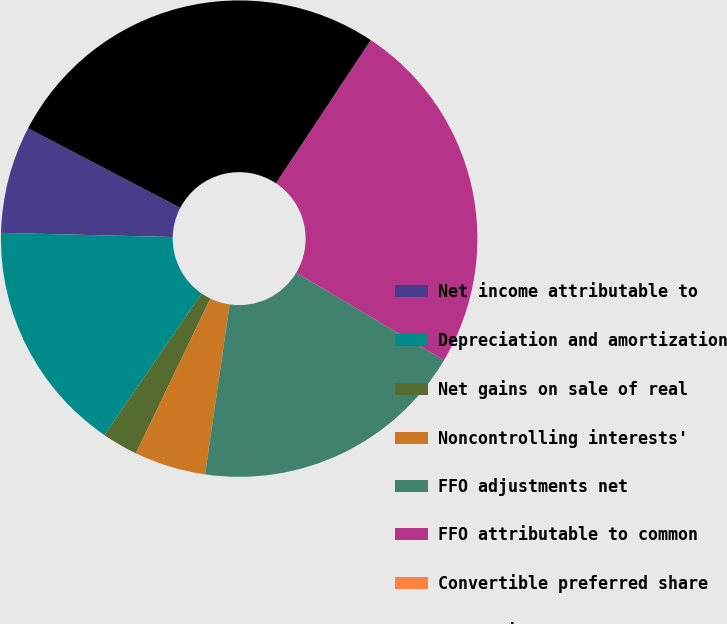<chart> <loc_0><loc_0><loc_500><loc_500><pie_chart><fcel>Net income attributable to<fcel>Depreciation and amortization<fcel>Net gains on sale of real<fcel>Noncontrolling interests'<fcel>FFO adjustments net<fcel>FFO attributable to common<fcel>Convertible preferred share<fcel>conversions<nl><fcel>7.28%<fcel>15.82%<fcel>2.43%<fcel>4.85%<fcel>18.75%<fcel>24.22%<fcel>0.0%<fcel>26.65%<nl></chart> 